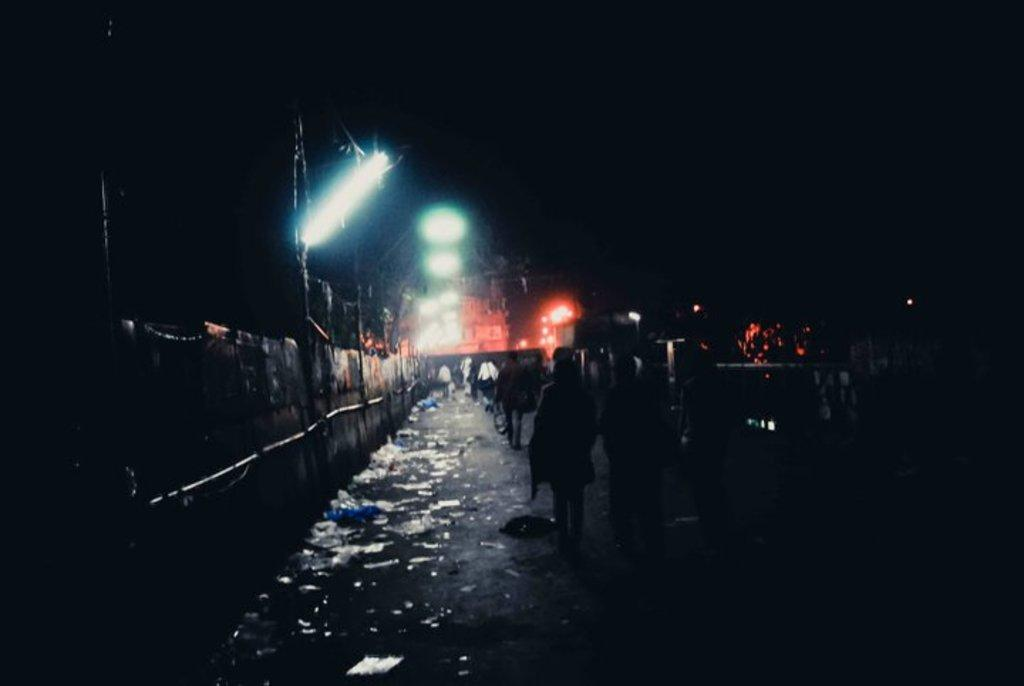What can be seen on the walkway in the image? There are people on the walkway in the image. What type of structures are visible in the image? There are walls visible in the image. What are the rods used for in the image? The purpose of the rods in the image is not specified, but they could be used for various purposes such as support or decoration. What type of lighting is present in the image? Street lights are present in the image. How would you describe the lighting conditions in the image? The background of the image is dark. What type of tin is being used to make bread in the image? There is no tin or bread present in the image. How does the health of the people on the walkway appear in the image? The image does not provide any information about the health of the people on the walkway. 